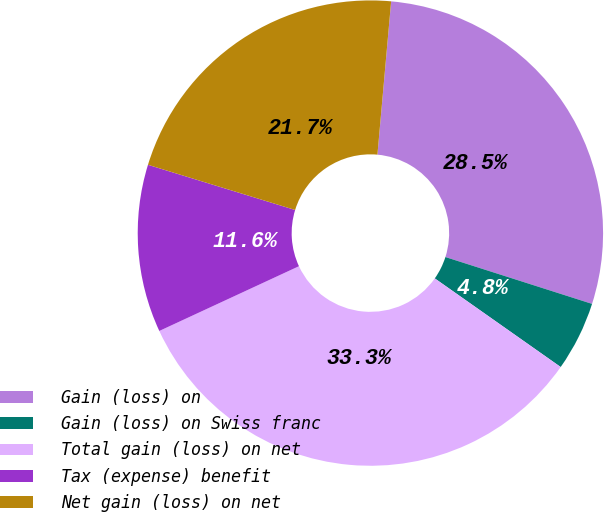Convert chart to OTSL. <chart><loc_0><loc_0><loc_500><loc_500><pie_chart><fcel>Gain (loss) on<fcel>Gain (loss) on Swiss franc<fcel>Total gain (loss) on net<fcel>Tax (expense) benefit<fcel>Net gain (loss) on net<nl><fcel>28.5%<fcel>4.84%<fcel>33.33%<fcel>11.65%<fcel>21.68%<nl></chart> 